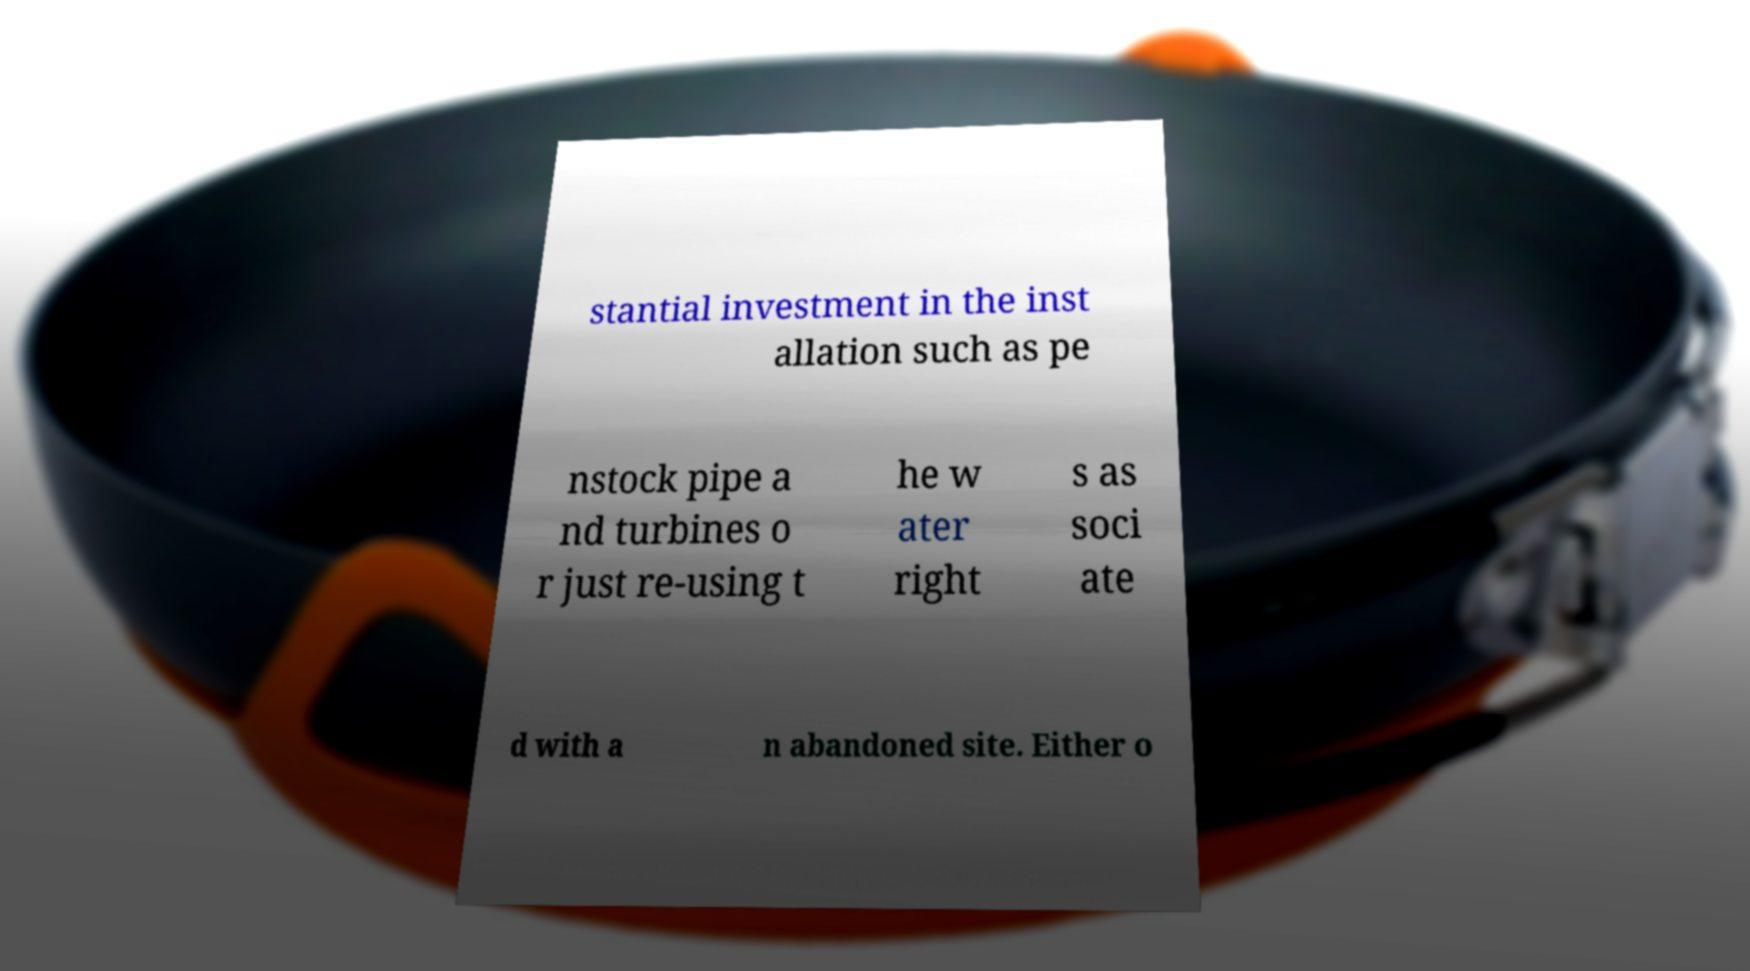Please read and relay the text visible in this image. What does it say? stantial investment in the inst allation such as pe nstock pipe a nd turbines o r just re-using t he w ater right s as soci ate d with a n abandoned site. Either o 